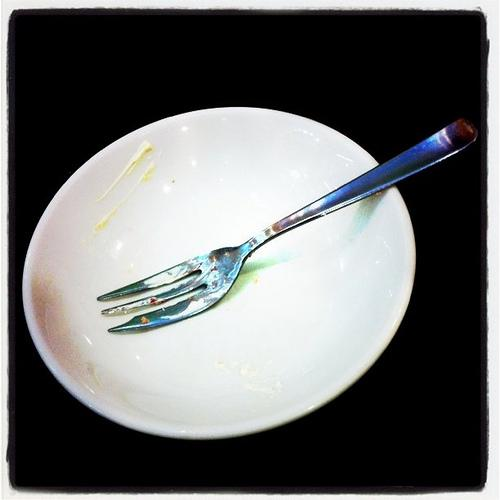What is the color and condition of the tablecloth in the picture? The tablecloth is black and has a plate and fork on it. Mention the color of the fork and how many pointed parts it has. The fork is silver and has three pointed parts. Describe the appearance of the frosting on the white plate in the image. The frosting on the white plate appears as splotches around the plate in various sizes. Can you identify any specific part of the fork, and if so, what is it? Yes, the handle of the fork can be identified. What can be said about the state of the food residue and prongs of the fork in the picture? The fork is dirty with some food residue still on it and has three prongs. Is there any food item visible in the image, and if so, what color is it? Yes, there is yellow cream on the plate. What is the shape of the plate, and how can its cleanliness be described? The plate is round and has been described as dirty and not clean. Specify the relationship between the fork and the plate in the image. The fork is placed on the white plate. Explain the presence of any shadows or reflections in the image. There is a light reflection on the plate and a shadow of the fork. What is the color of the plate and the tablecloth in the image? The plate is white and the tablecloth is black. 